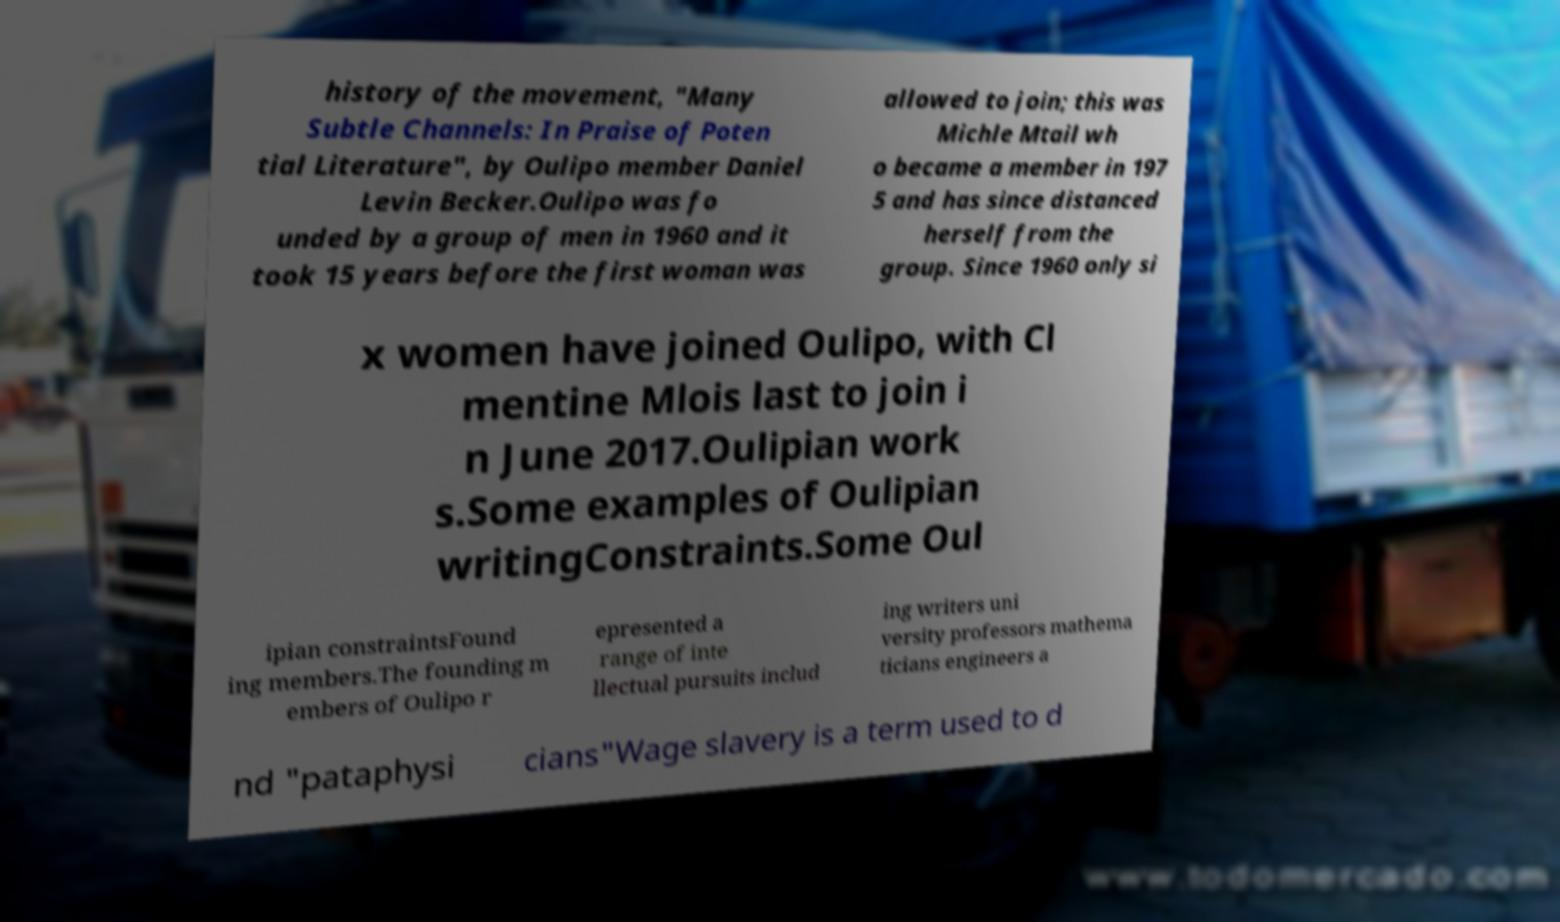Please read and relay the text visible in this image. What does it say? history of the movement, "Many Subtle Channels: In Praise of Poten tial Literature", by Oulipo member Daniel Levin Becker.Oulipo was fo unded by a group of men in 1960 and it took 15 years before the first woman was allowed to join; this was Michle Mtail wh o became a member in 197 5 and has since distanced herself from the group. Since 1960 only si x women have joined Oulipo, with Cl mentine Mlois last to join i n June 2017.Oulipian work s.Some examples of Oulipian writingConstraints.Some Oul ipian constraintsFound ing members.The founding m embers of Oulipo r epresented a range of inte llectual pursuits includ ing writers uni versity professors mathema ticians engineers a nd "pataphysi cians"Wage slavery is a term used to d 